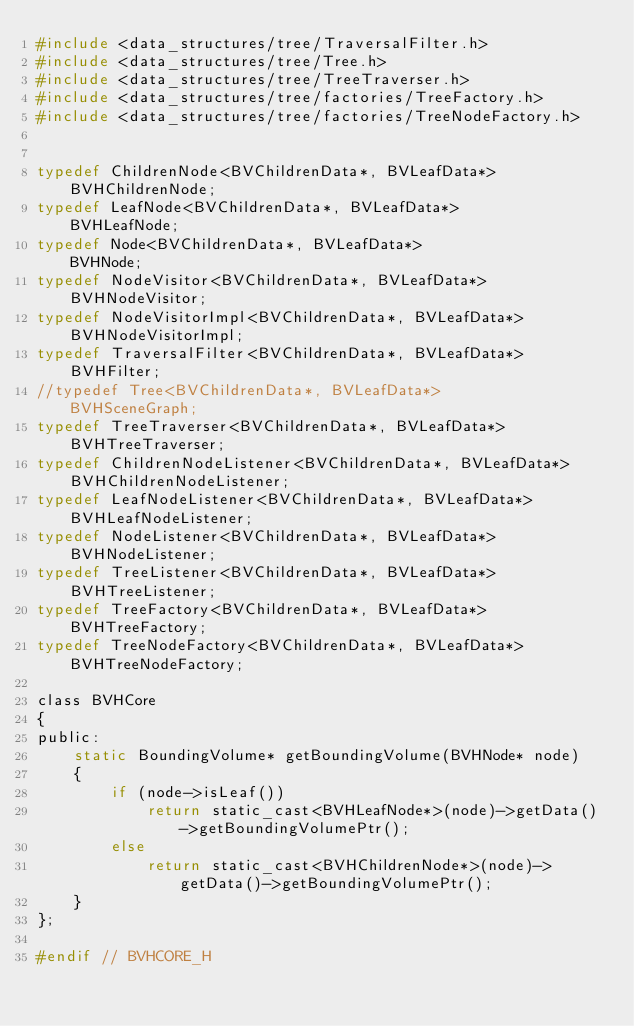<code> <loc_0><loc_0><loc_500><loc_500><_C_>#include <data_structures/tree/TraversalFilter.h>
#include <data_structures/tree/Tree.h>
#include <data_structures/tree/TreeTraverser.h>
#include <data_structures/tree/factories/TreeFactory.h>
#include <data_structures/tree/factories/TreeNodeFactory.h>


typedef ChildrenNode<BVChildrenData*, BVLeafData*>          BVHChildrenNode;
typedef LeafNode<BVChildrenData*, BVLeafData*>              BVHLeafNode;
typedef Node<BVChildrenData*, BVLeafData*>                  BVHNode;
typedef NodeVisitor<BVChildrenData*, BVLeafData*>           BVHNodeVisitor;
typedef NodeVisitorImpl<BVChildrenData*, BVLeafData*>       BVHNodeVisitorImpl;
typedef TraversalFilter<BVChildrenData*, BVLeafData*>       BVHFilter;
//typedef Tree<BVChildrenData*, BVLeafData*>                  BVHSceneGraph;
typedef TreeTraverser<BVChildrenData*, BVLeafData*>         BVHTreeTraverser;
typedef ChildrenNodeListener<BVChildrenData*, BVLeafData*>  BVHChildrenNodeListener;
typedef LeafNodeListener<BVChildrenData*, BVLeafData*>      BVHLeafNodeListener;
typedef NodeListener<BVChildrenData*, BVLeafData*>          BVHNodeListener;
typedef TreeListener<BVChildrenData*, BVLeafData*>          BVHTreeListener;
typedef TreeFactory<BVChildrenData*, BVLeafData*>           BVHTreeFactory;
typedef TreeNodeFactory<BVChildrenData*, BVLeafData*>       BVHTreeNodeFactory;

class BVHCore
{
public:
    static BoundingVolume* getBoundingVolume(BVHNode* node)
    {
        if (node->isLeaf())
            return static_cast<BVHLeafNode*>(node)->getData()->getBoundingVolumePtr();
        else
            return static_cast<BVHChildrenNode*>(node)->getData()->getBoundingVolumePtr();
    }
};

#endif // BVHCORE_H
</code> 